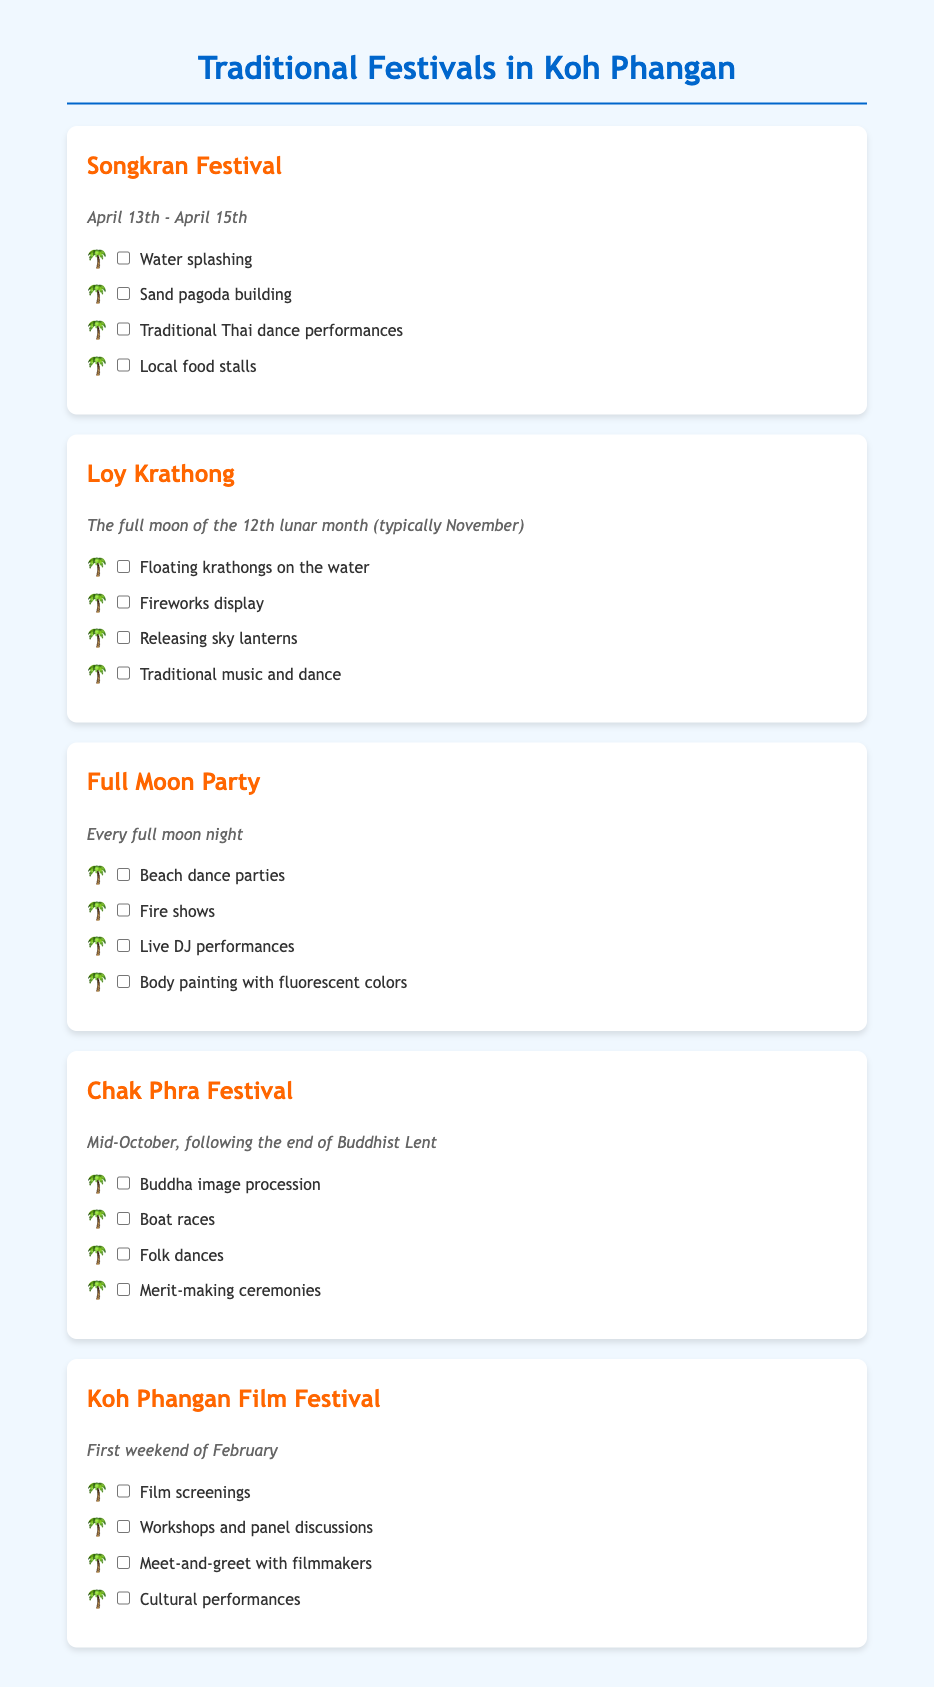What is the date of the Songkran Festival? The Songkran Festival takes place from April 13th to April 15th.
Answer: April 13th - April 15th What activities are included in the Loy Krathong festival? The activities for Loy Krathong include floating krathongs, fireworks, releasing sky lanterns, and traditional music and dance.
Answer: Floating krathongs on the water When does the Full Moon Party occur? The Full Moon Party occurs every month on the night of the full moon.
Answer: Every full moon night What festival features a Buddha image procession? The Chak Phra Festival features a Buddha image procession as one of its activities.
Answer: Chak Phra Festival In which month does the Koh Phangan Film Festival take place? The Koh Phangan Film Festival occurs on the first weekend of February.
Answer: February What is the primary purpose of the activities in the Chak Phra Festival? The primary purpose of the activities in the Chak Phra Festival includes merit-making ceremonies.
Answer: Merit-making ceremonies How many days does the Songkran Festival last? The Songkran Festival lasts for three days.
Answer: Three days What type of celebrations are featured in the Full Moon Party? The celebrations during the Full Moon Party feature beach dance parties and fire shows.
Answer: Beach dance parties What is the date range for Loy Krathong? The date for Loy Krathong is tied to the full moon of the 12th lunar month, which typically falls in November.
Answer: November 